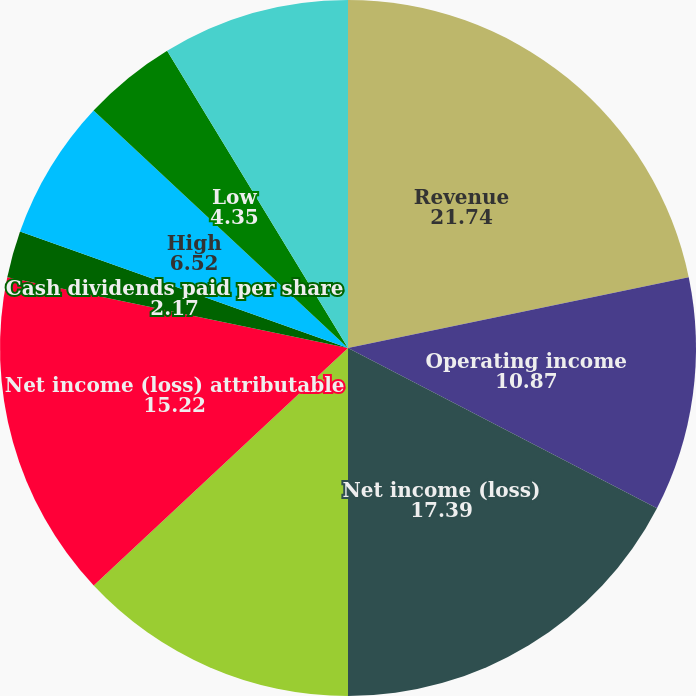Convert chart. <chart><loc_0><loc_0><loc_500><loc_500><pie_chart><fcel>Revenue<fcel>Operating income<fcel>Net income (loss)<fcel>Income (loss) from continuing<fcel>Net income (loss) attributable<fcel>Cash dividends paid per share<fcel>High<fcel>Low<fcel>Operating income (loss)<fcel>Basic and diluted net income<nl><fcel>21.74%<fcel>10.87%<fcel>17.39%<fcel>13.04%<fcel>15.22%<fcel>2.17%<fcel>6.52%<fcel>4.35%<fcel>8.7%<fcel>0.0%<nl></chart> 